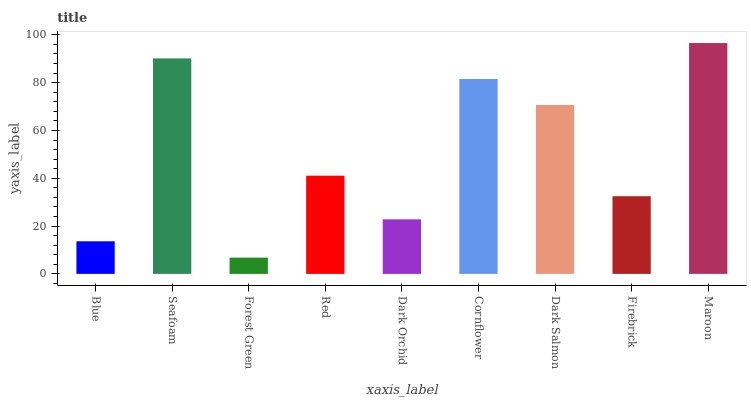Is Seafoam the minimum?
Answer yes or no. No. Is Seafoam the maximum?
Answer yes or no. No. Is Seafoam greater than Blue?
Answer yes or no. Yes. Is Blue less than Seafoam?
Answer yes or no. Yes. Is Blue greater than Seafoam?
Answer yes or no. No. Is Seafoam less than Blue?
Answer yes or no. No. Is Red the high median?
Answer yes or no. Yes. Is Red the low median?
Answer yes or no. Yes. Is Forest Green the high median?
Answer yes or no. No. Is Forest Green the low median?
Answer yes or no. No. 